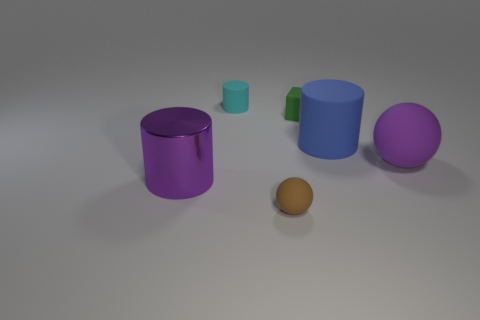How many other things are the same color as the shiny cylinder?
Offer a very short reply. 1. How many large cylinders are the same color as the large matte ball?
Offer a terse response. 1. There is another large thing that is the same shape as the big purple shiny object; what color is it?
Give a very brief answer. Blue. What material is the large purple cylinder?
Your answer should be very brief. Metal. There is another rubber thing that is the same shape as the blue object; what size is it?
Provide a succinct answer. Small. There is a matte object that is to the left of the small rubber sphere; are there any small green cubes that are on the right side of it?
Your response must be concise. Yes. Does the big shiny cylinder have the same color as the large rubber ball?
Your answer should be very brief. Yes. What number of other things are there of the same shape as the green rubber object?
Give a very brief answer. 0. Are there more matte things that are in front of the large blue thing than small things that are behind the purple matte object?
Your response must be concise. No. There is a purple thing to the left of the big purple sphere; is it the same size as the matte object behind the small rubber cube?
Offer a terse response. No. 